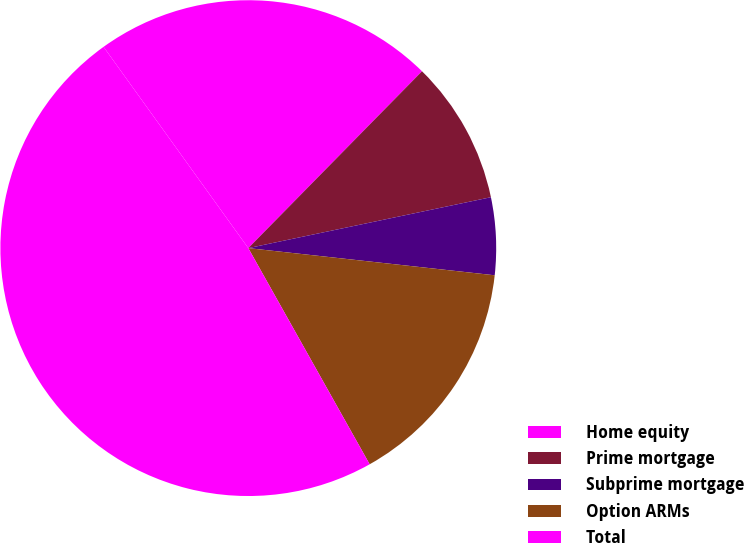<chart> <loc_0><loc_0><loc_500><loc_500><pie_chart><fcel>Home equity<fcel>Prime mortgage<fcel>Subprime mortgage<fcel>Option ARMs<fcel>Total<nl><fcel>22.28%<fcel>9.35%<fcel>5.04%<fcel>15.11%<fcel>48.22%<nl></chart> 